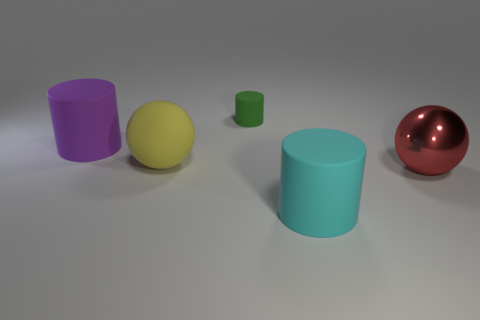Add 3 small green things. How many objects exist? 8 Subtract all cylinders. How many objects are left? 2 Subtract all tiny purple shiny objects. Subtract all purple rubber objects. How many objects are left? 4 Add 2 matte cylinders. How many matte cylinders are left? 5 Add 2 cyan things. How many cyan things exist? 3 Subtract 0 cyan spheres. How many objects are left? 5 